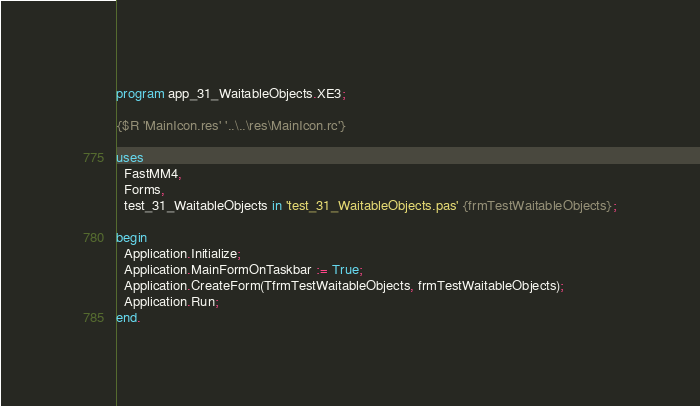Convert code to text. <code><loc_0><loc_0><loc_500><loc_500><_Pascal_>program app_31_WaitableObjects.XE3;

{$R 'MainIcon.res' '..\..\res\MainIcon.rc'}

uses
  FastMM4,
  Forms,
  test_31_WaitableObjects in 'test_31_WaitableObjects.pas' {frmTestWaitableObjects};

begin
  Application.Initialize;
  Application.MainFormOnTaskbar := True;
  Application.CreateForm(TfrmTestWaitableObjects, frmTestWaitableObjects);
  Application.Run;
end.
</code> 